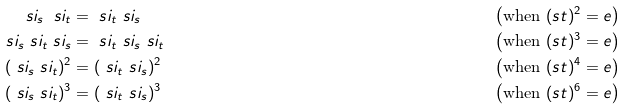Convert formula to latex. <formula><loc_0><loc_0><loc_500><loc_500>\ s i _ { s } \ s i _ { t } & = \ s i _ { t } \ s i _ { s } & \left ( \text {when } ( s t ) ^ { 2 } = e \right ) \\ \ s i _ { s } \ s i _ { t } \ s i _ { s } & = \ s i _ { t } \ s i _ { s } \ s i _ { t } & \left ( \text {when } ( s t ) ^ { 3 } = e \right ) \\ ( \ s i _ { s } \ s i _ { t } ) ^ { 2 } & = ( \ s i _ { t } \ s i _ { s } ) ^ { 2 } & \left ( \text {when } ( s t ) ^ { 4 } = e \right ) \\ ( \ s i _ { s } \ s i _ { t } ) ^ { 3 } & = ( \ s i _ { t } \ s i _ { s } ) ^ { 3 } & \left ( \text {when } ( s t ) ^ { 6 } = e \right )</formula> 